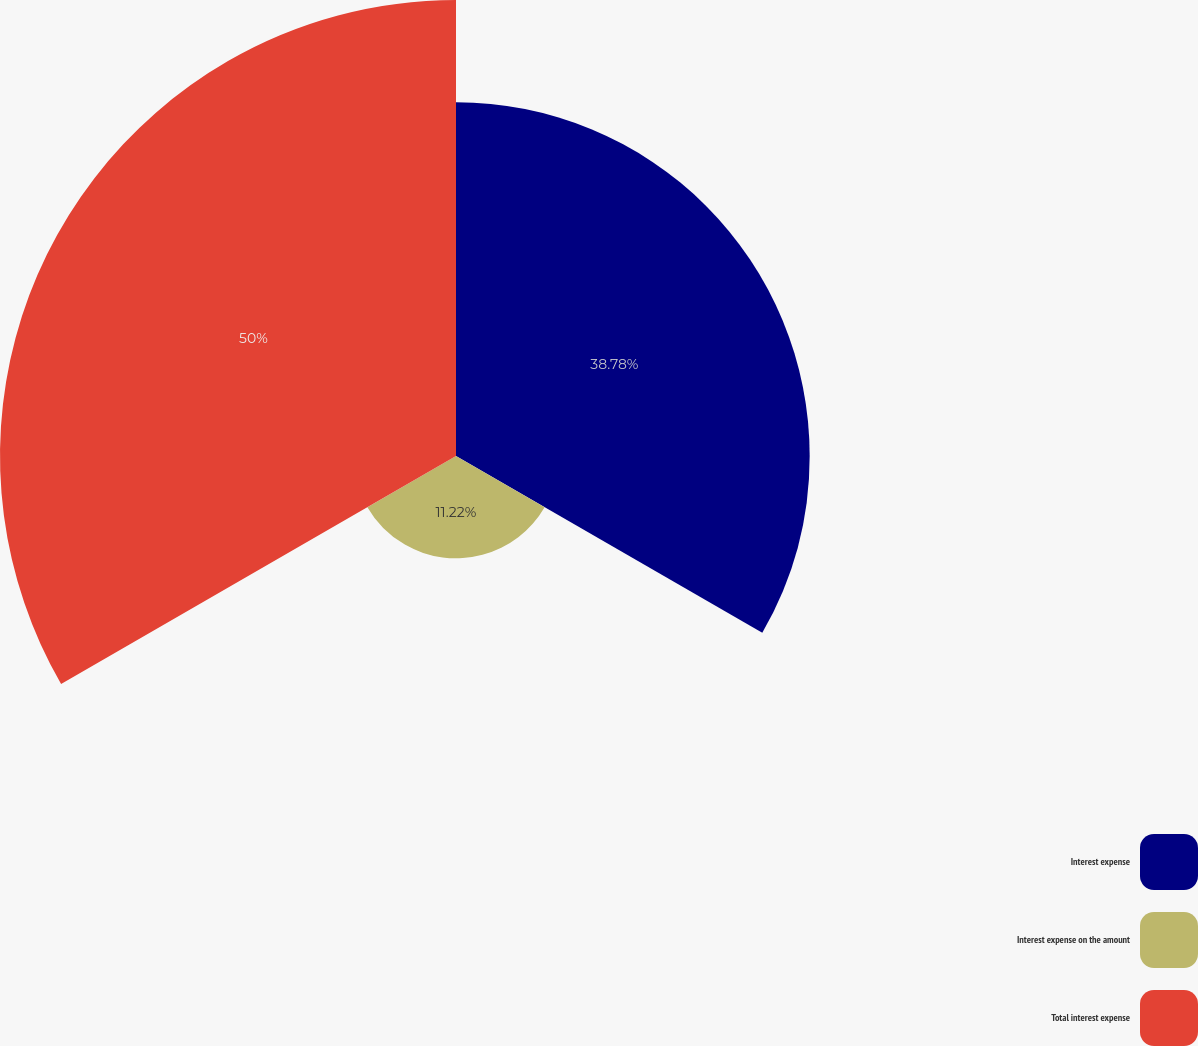<chart> <loc_0><loc_0><loc_500><loc_500><pie_chart><fcel>Interest expense<fcel>Interest expense on the amount<fcel>Total interest expense<nl><fcel>38.78%<fcel>11.22%<fcel>50.0%<nl></chart> 